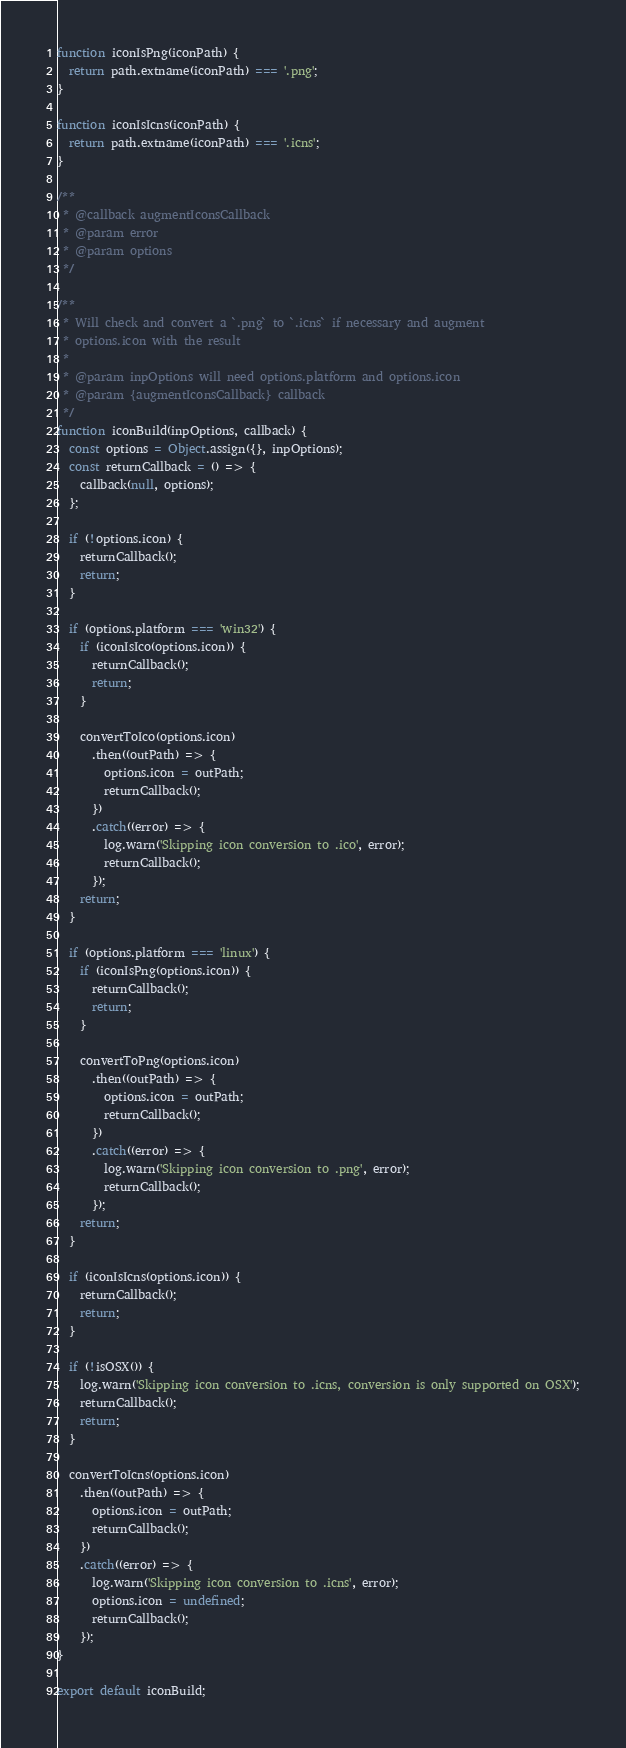Convert code to text. <code><loc_0><loc_0><loc_500><loc_500><_JavaScript_>function iconIsPng(iconPath) {
  return path.extname(iconPath) === '.png';
}

function iconIsIcns(iconPath) {
  return path.extname(iconPath) === '.icns';
}

/**
 * @callback augmentIconsCallback
 * @param error
 * @param options
 */

/**
 * Will check and convert a `.png` to `.icns` if necessary and augment
 * options.icon with the result
 *
 * @param inpOptions will need options.platform and options.icon
 * @param {augmentIconsCallback} callback
 */
function iconBuild(inpOptions, callback) {
  const options = Object.assign({}, inpOptions);
  const returnCallback = () => {
    callback(null, options);
  };

  if (!options.icon) {
    returnCallback();
    return;
  }

  if (options.platform === 'win32') {
    if (iconIsIco(options.icon)) {
      returnCallback();
      return;
    }

    convertToIco(options.icon)
      .then((outPath) => {
        options.icon = outPath;
        returnCallback();
      })
      .catch((error) => {
        log.warn('Skipping icon conversion to .ico', error);
        returnCallback();
      });
    return;
  }

  if (options.platform === 'linux') {
    if (iconIsPng(options.icon)) {
      returnCallback();
      return;
    }

    convertToPng(options.icon)
      .then((outPath) => {
        options.icon = outPath;
        returnCallback();
      })
      .catch((error) => {
        log.warn('Skipping icon conversion to .png', error);
        returnCallback();
      });
    return;
  }

  if (iconIsIcns(options.icon)) {
    returnCallback();
    return;
  }

  if (!isOSX()) {
    log.warn('Skipping icon conversion to .icns, conversion is only supported on OSX');
    returnCallback();
    return;
  }

  convertToIcns(options.icon)
    .then((outPath) => {
      options.icon = outPath;
      returnCallback();
    })
    .catch((error) => {
      log.warn('Skipping icon conversion to .icns', error);
      options.icon = undefined;
      returnCallback();
    });
}

export default iconBuild;
</code> 